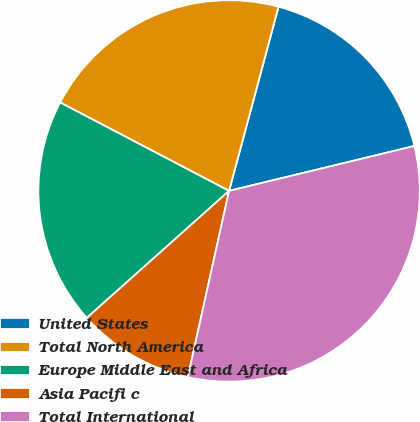Convert chart. <chart><loc_0><loc_0><loc_500><loc_500><pie_chart><fcel>United States<fcel>Total North America<fcel>Europe Middle East and Africa<fcel>Asia Pacifi c<fcel>Total International<nl><fcel>17.04%<fcel>21.5%<fcel>19.27%<fcel>9.93%<fcel>32.25%<nl></chart> 